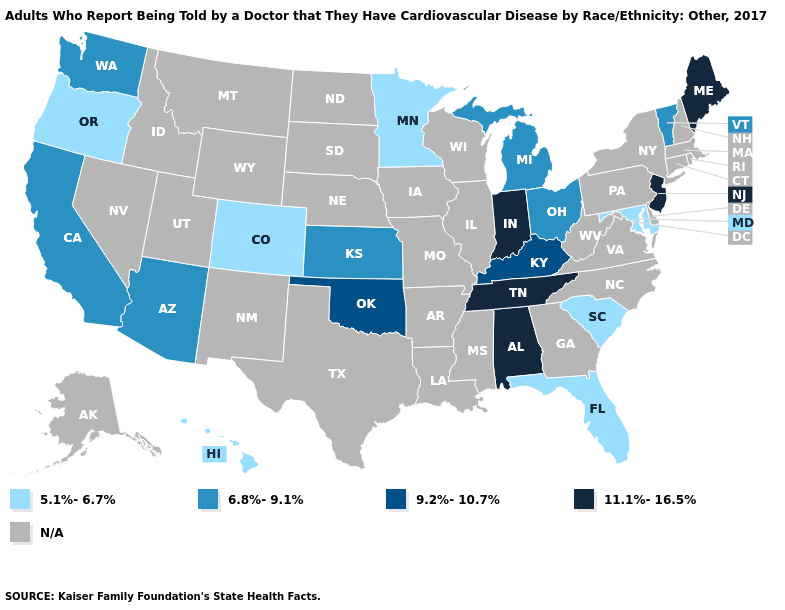Among the states that border Arkansas , which have the highest value?
Keep it brief. Tennessee. What is the value of Kansas?
Short answer required. 6.8%-9.1%. Does Vermont have the lowest value in the Northeast?
Be succinct. Yes. What is the value of Washington?
Keep it brief. 6.8%-9.1%. Which states have the highest value in the USA?
Quick response, please. Alabama, Indiana, Maine, New Jersey, Tennessee. Does the first symbol in the legend represent the smallest category?
Give a very brief answer. Yes. Among the states that border Michigan , does Ohio have the highest value?
Be succinct. No. Name the states that have a value in the range N/A?
Short answer required. Alaska, Arkansas, Connecticut, Delaware, Georgia, Idaho, Illinois, Iowa, Louisiana, Massachusetts, Mississippi, Missouri, Montana, Nebraska, Nevada, New Hampshire, New Mexico, New York, North Carolina, North Dakota, Pennsylvania, Rhode Island, South Dakota, Texas, Utah, Virginia, West Virginia, Wisconsin, Wyoming. What is the lowest value in the USA?
Be succinct. 5.1%-6.7%. What is the value of Washington?
Answer briefly. 6.8%-9.1%. Which states have the lowest value in the USA?
Answer briefly. Colorado, Florida, Hawaii, Maryland, Minnesota, Oregon, South Carolina. Name the states that have a value in the range 9.2%-10.7%?
Keep it brief. Kentucky, Oklahoma. Name the states that have a value in the range 6.8%-9.1%?
Give a very brief answer. Arizona, California, Kansas, Michigan, Ohio, Vermont, Washington. Name the states that have a value in the range 11.1%-16.5%?
Be succinct. Alabama, Indiana, Maine, New Jersey, Tennessee. Name the states that have a value in the range N/A?
Concise answer only. Alaska, Arkansas, Connecticut, Delaware, Georgia, Idaho, Illinois, Iowa, Louisiana, Massachusetts, Mississippi, Missouri, Montana, Nebraska, Nevada, New Hampshire, New Mexico, New York, North Carolina, North Dakota, Pennsylvania, Rhode Island, South Dakota, Texas, Utah, Virginia, West Virginia, Wisconsin, Wyoming. 